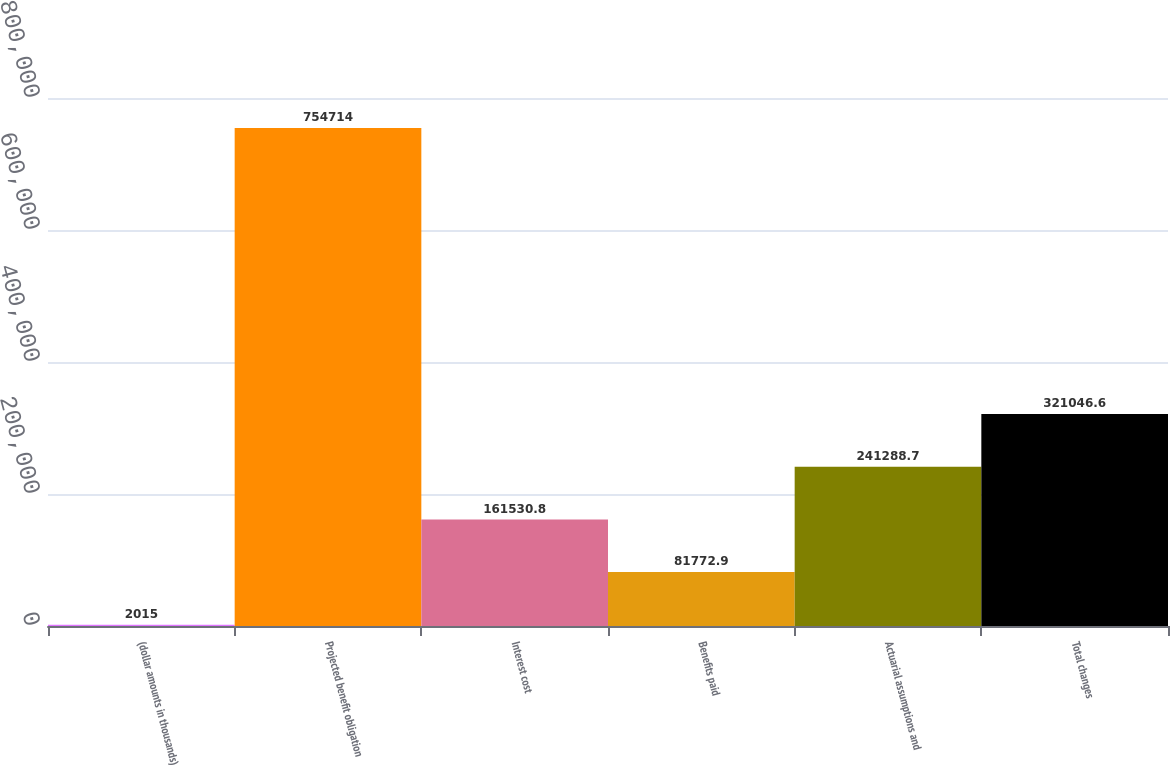<chart> <loc_0><loc_0><loc_500><loc_500><bar_chart><fcel>(dollar amounts in thousands)<fcel>Projected benefit obligation<fcel>Interest cost<fcel>Benefits paid<fcel>Actuarial assumptions and<fcel>Total changes<nl><fcel>2015<fcel>754714<fcel>161531<fcel>81772.9<fcel>241289<fcel>321047<nl></chart> 